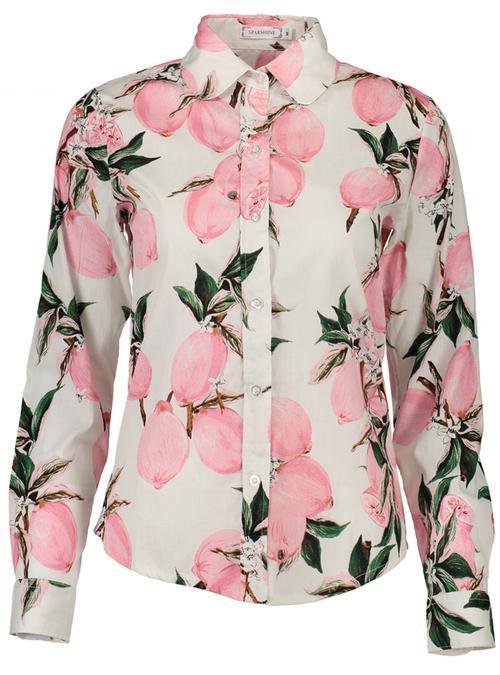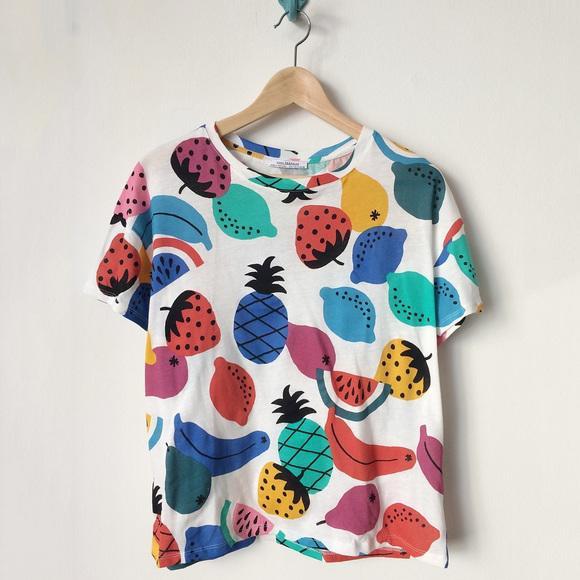The first image is the image on the left, the second image is the image on the right. Analyze the images presented: Is the assertion "Each image contains a top with a printed pattern that includes pink fruits." valid? Answer yes or no. Yes. The first image is the image on the left, the second image is the image on the right. Analyze the images presented: Is the assertion "One shirt is on a hanger." valid? Answer yes or no. Yes. 